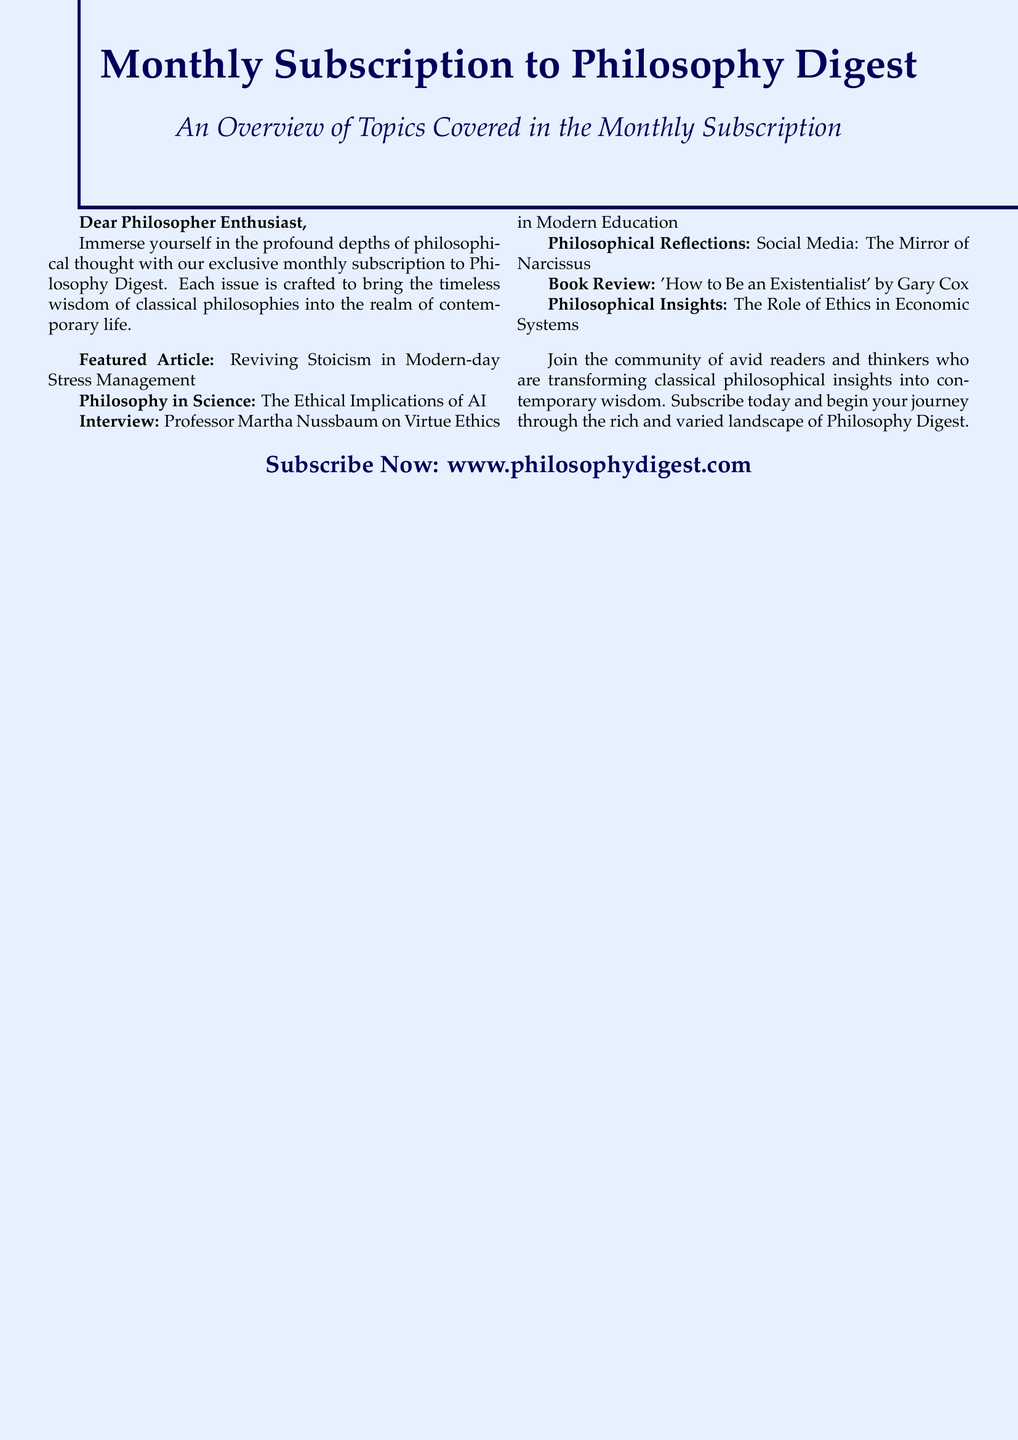What is the title of the featured article? The featured article is listed as the first topic in the document.
Answer: Reviving Stoicism in Modern-day Stress Management Who is interviewed in this issue? The interview section names a specific individual in modern education.
Answer: Professor Martha Nussbaum What is one of the philosophical insights discussed? The document lists various insights, and one is regarding ethics.
Answer: The Role of Ethics in Economic Systems What is the website for subscribing? The subscription information provides a specific URL for readers.
Answer: www.philosophydigest.com How many main topics are highlighted in the document? The document explicitly lists six main topics covered in the subscription.
Answer: Six What is the genre of the book reviewed? The book review mentions a particular philosophical genre related to existence.
Answer: Existentialism What does the Philosophy Digest aim to transform? The text indicates what the publication aims to achieve for its readers.
Answer: Classical philosophical insights into contemporary wisdom 